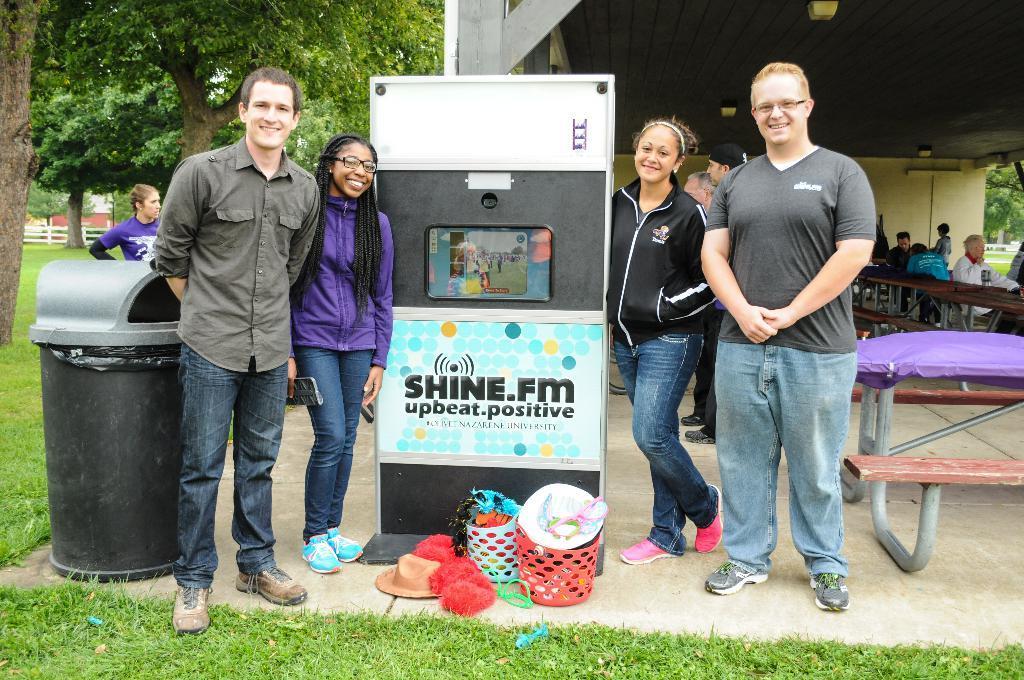Describe this image in one or two sentences. In this image I can see few people with different color dresses. To the side of these people I can see the board. To the left there is a dustbin. And I can see few baskets, hats and some clothes in-front of the board. To the right I can see few people siting. In the background there are many trees and the shed. 